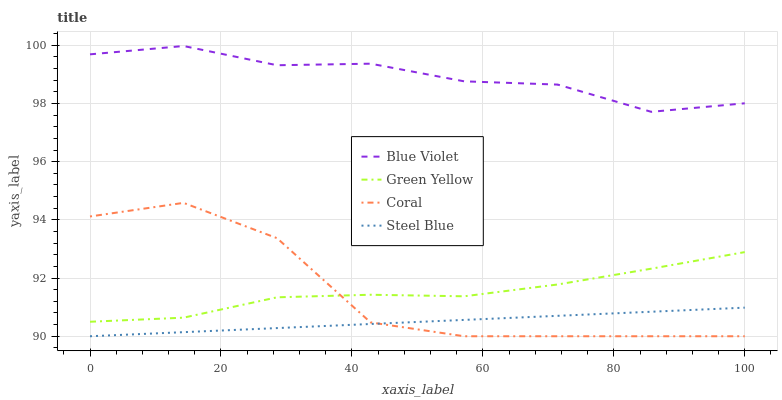Does Green Yellow have the minimum area under the curve?
Answer yes or no. No. Does Green Yellow have the maximum area under the curve?
Answer yes or no. No. Is Green Yellow the smoothest?
Answer yes or no. No. Is Green Yellow the roughest?
Answer yes or no. No. Does Green Yellow have the lowest value?
Answer yes or no. No. Does Green Yellow have the highest value?
Answer yes or no. No. Is Steel Blue less than Blue Violet?
Answer yes or no. Yes. Is Blue Violet greater than Green Yellow?
Answer yes or no. Yes. Does Steel Blue intersect Blue Violet?
Answer yes or no. No. 